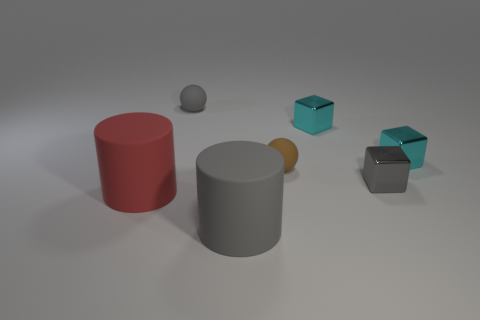What shape is the thing that is the same size as the gray rubber cylinder?
Keep it short and to the point. Cylinder. Is the number of brown things that are in front of the tiny brown thing less than the number of brown matte balls to the left of the small gray rubber sphere?
Provide a short and direct response. No. Is there anything else that is the same shape as the large gray rubber object?
Offer a terse response. Yes. There is a gray cylinder that is in front of the small gray cube; what is its material?
Your response must be concise. Rubber. Is there anything else that is the same size as the gray matte ball?
Make the answer very short. Yes. There is a small gray block; are there any brown rubber objects on the right side of it?
Make the answer very short. No. The gray metallic thing has what shape?
Your response must be concise. Cube. What number of objects are cylinders that are right of the red matte cylinder or large gray matte cylinders?
Provide a succinct answer. 1. What is the color of the other big matte thing that is the same shape as the red matte object?
Your response must be concise. Gray. Does the big red thing have the same material as the cylinder right of the large red cylinder?
Provide a short and direct response. Yes. 